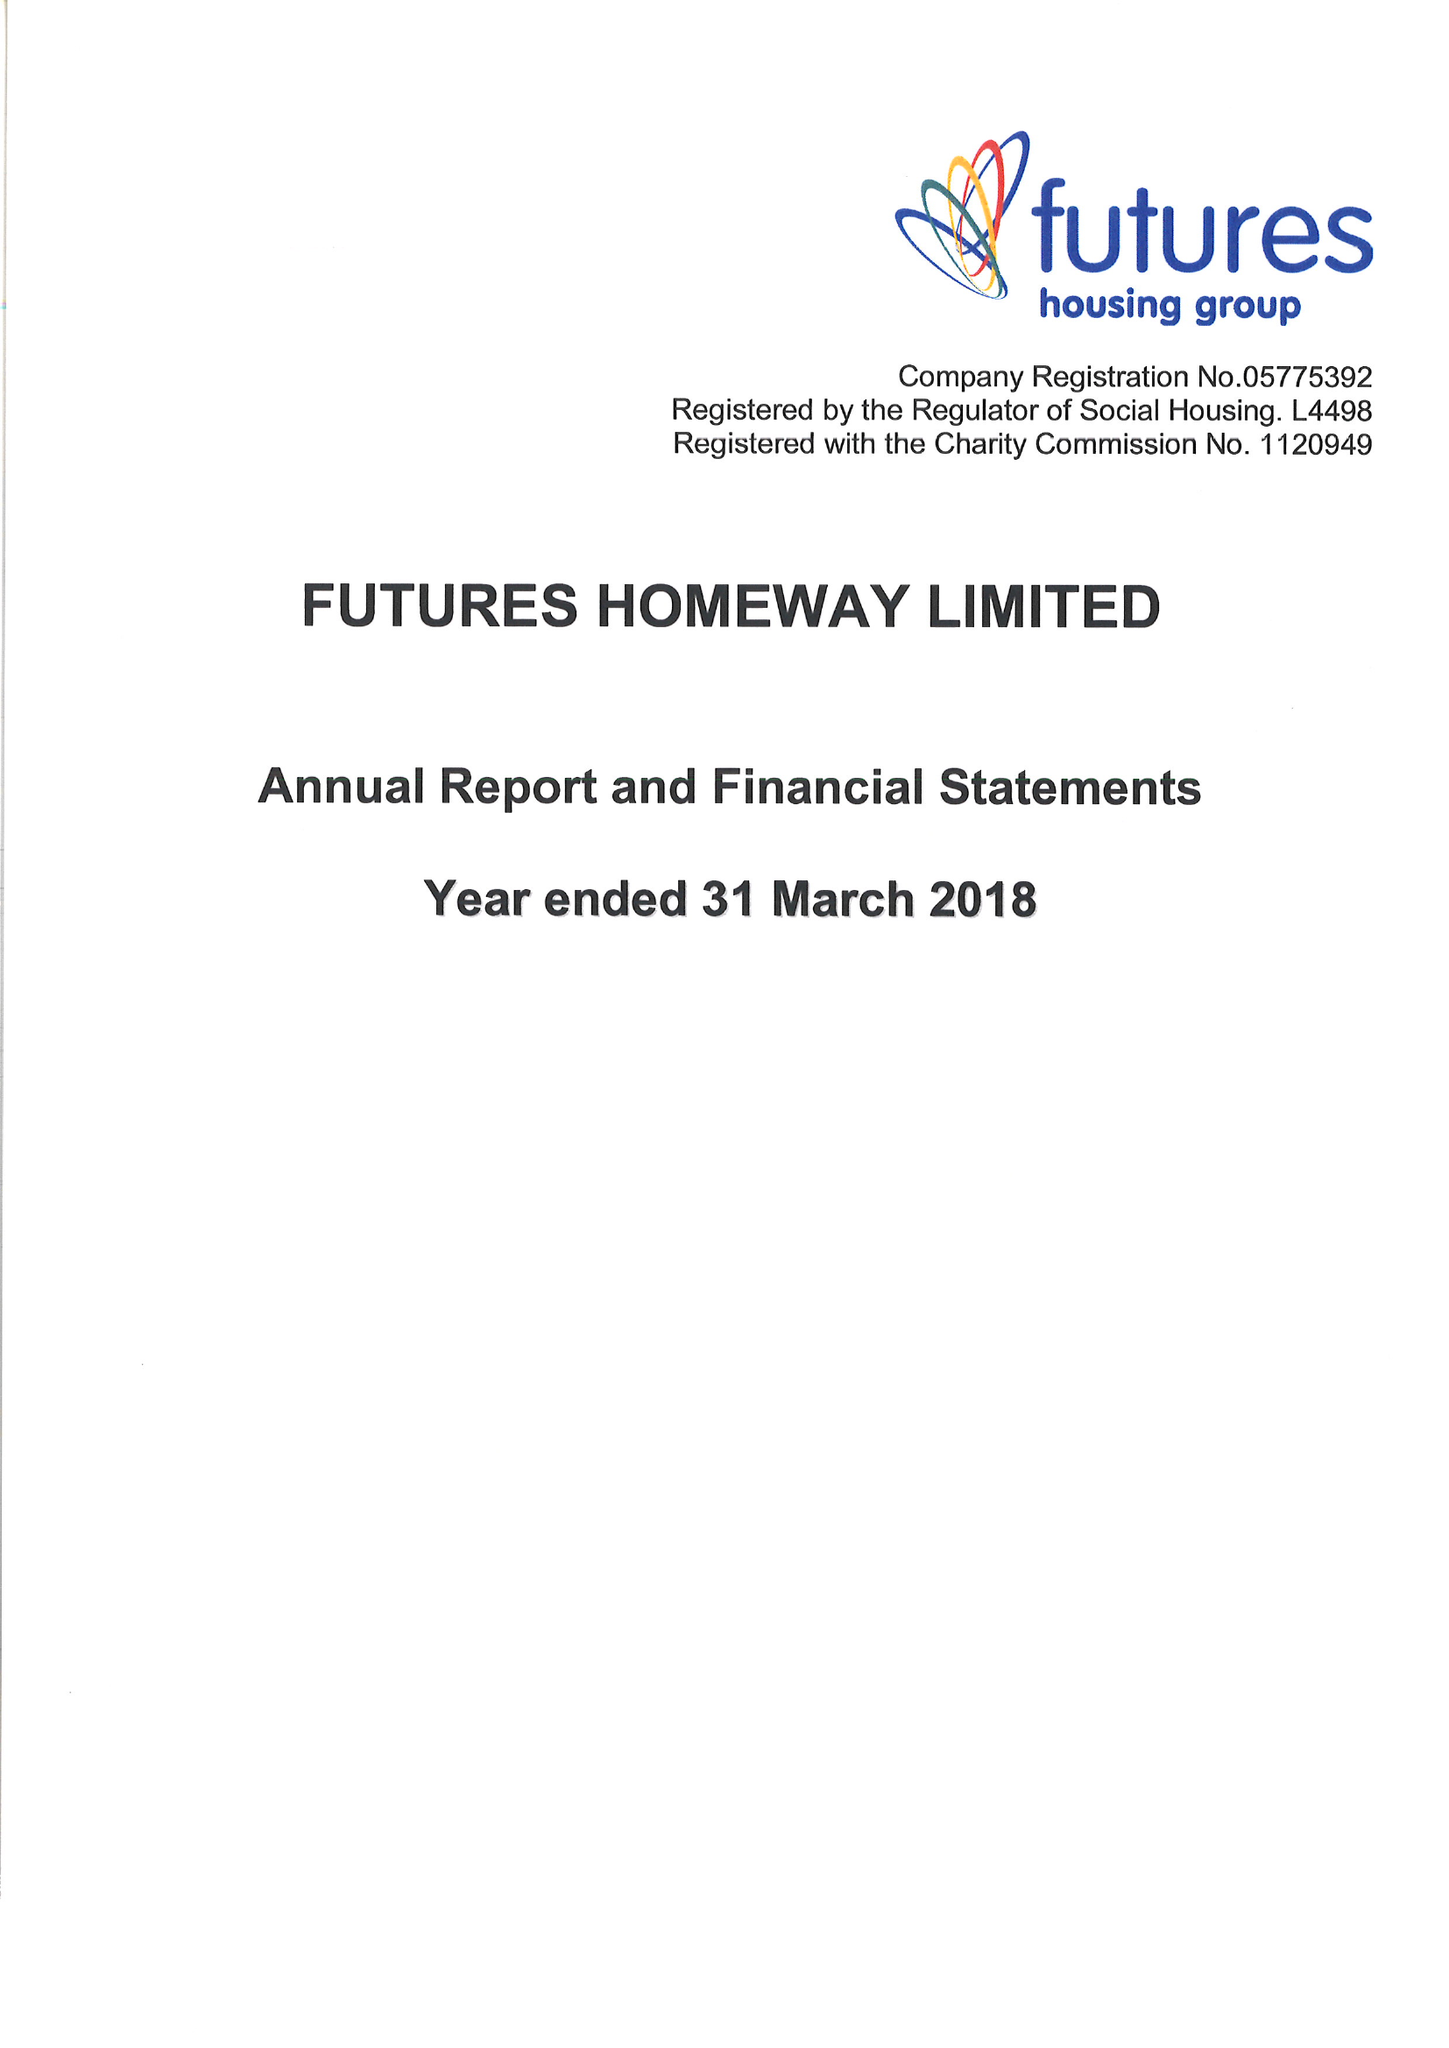What is the value for the report_date?
Answer the question using a single word or phrase. 2018-03-31 